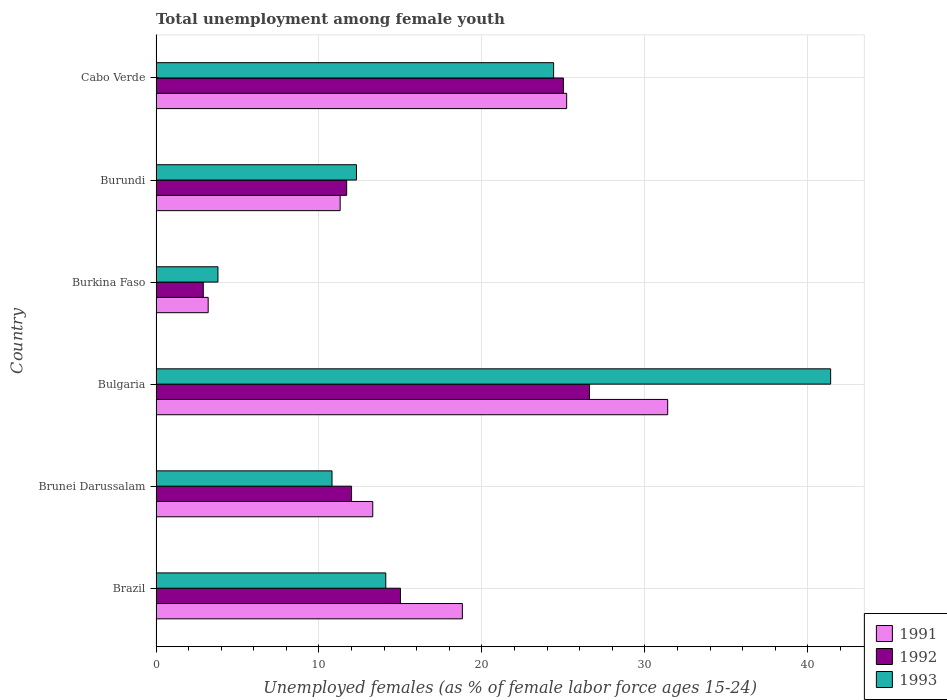How many different coloured bars are there?
Provide a succinct answer. 3. How many groups of bars are there?
Your answer should be very brief. 6. How many bars are there on the 5th tick from the top?
Provide a succinct answer. 3. How many bars are there on the 1st tick from the bottom?
Your answer should be compact. 3. What is the label of the 1st group of bars from the top?
Give a very brief answer. Cabo Verde. In how many cases, is the number of bars for a given country not equal to the number of legend labels?
Ensure brevity in your answer.  0. What is the percentage of unemployed females in in 1993 in Burkina Faso?
Provide a succinct answer. 3.8. Across all countries, what is the maximum percentage of unemployed females in in 1991?
Make the answer very short. 31.4. Across all countries, what is the minimum percentage of unemployed females in in 1991?
Your answer should be very brief. 3.2. In which country was the percentage of unemployed females in in 1991 minimum?
Make the answer very short. Burkina Faso. What is the total percentage of unemployed females in in 1991 in the graph?
Your answer should be very brief. 103.2. What is the difference between the percentage of unemployed females in in 1993 in Brunei Darussalam and that in Cabo Verde?
Offer a very short reply. -13.6. What is the difference between the percentage of unemployed females in in 1992 in Brazil and the percentage of unemployed females in in 1991 in Bulgaria?
Your answer should be very brief. -16.4. What is the average percentage of unemployed females in in 1992 per country?
Provide a short and direct response. 15.53. What is the difference between the percentage of unemployed females in in 1991 and percentage of unemployed females in in 1992 in Brunei Darussalam?
Give a very brief answer. 1.3. What is the ratio of the percentage of unemployed females in in 1991 in Bulgaria to that in Burundi?
Give a very brief answer. 2.78. Is the percentage of unemployed females in in 1993 in Brunei Darussalam less than that in Burundi?
Your answer should be compact. Yes. Is the difference between the percentage of unemployed females in in 1991 in Burundi and Cabo Verde greater than the difference between the percentage of unemployed females in in 1992 in Burundi and Cabo Verde?
Make the answer very short. No. What is the difference between the highest and the second highest percentage of unemployed females in in 1991?
Give a very brief answer. 6.2. What is the difference between the highest and the lowest percentage of unemployed females in in 1992?
Your response must be concise. 23.7. Is the sum of the percentage of unemployed females in in 1991 in Brazil and Bulgaria greater than the maximum percentage of unemployed females in in 1993 across all countries?
Your answer should be very brief. Yes. What does the 1st bar from the top in Brunei Darussalam represents?
Keep it short and to the point. 1993. How many bars are there?
Give a very brief answer. 18. How many countries are there in the graph?
Give a very brief answer. 6. Are the values on the major ticks of X-axis written in scientific E-notation?
Offer a terse response. No. Where does the legend appear in the graph?
Offer a very short reply. Bottom right. How many legend labels are there?
Your answer should be very brief. 3. What is the title of the graph?
Provide a succinct answer. Total unemployment among female youth. Does "2011" appear as one of the legend labels in the graph?
Ensure brevity in your answer.  No. What is the label or title of the X-axis?
Provide a short and direct response. Unemployed females (as % of female labor force ages 15-24). What is the label or title of the Y-axis?
Your response must be concise. Country. What is the Unemployed females (as % of female labor force ages 15-24) in 1991 in Brazil?
Your response must be concise. 18.8. What is the Unemployed females (as % of female labor force ages 15-24) in 1993 in Brazil?
Provide a short and direct response. 14.1. What is the Unemployed females (as % of female labor force ages 15-24) in 1991 in Brunei Darussalam?
Ensure brevity in your answer.  13.3. What is the Unemployed females (as % of female labor force ages 15-24) in 1993 in Brunei Darussalam?
Offer a terse response. 10.8. What is the Unemployed females (as % of female labor force ages 15-24) in 1991 in Bulgaria?
Offer a terse response. 31.4. What is the Unemployed females (as % of female labor force ages 15-24) of 1992 in Bulgaria?
Your answer should be very brief. 26.6. What is the Unemployed females (as % of female labor force ages 15-24) of 1993 in Bulgaria?
Ensure brevity in your answer.  41.4. What is the Unemployed females (as % of female labor force ages 15-24) in 1991 in Burkina Faso?
Provide a succinct answer. 3.2. What is the Unemployed females (as % of female labor force ages 15-24) in 1992 in Burkina Faso?
Offer a terse response. 2.9. What is the Unemployed females (as % of female labor force ages 15-24) of 1993 in Burkina Faso?
Keep it short and to the point. 3.8. What is the Unemployed females (as % of female labor force ages 15-24) of 1991 in Burundi?
Ensure brevity in your answer.  11.3. What is the Unemployed females (as % of female labor force ages 15-24) of 1992 in Burundi?
Provide a short and direct response. 11.7. What is the Unemployed females (as % of female labor force ages 15-24) in 1993 in Burundi?
Make the answer very short. 12.3. What is the Unemployed females (as % of female labor force ages 15-24) of 1991 in Cabo Verde?
Your answer should be very brief. 25.2. What is the Unemployed females (as % of female labor force ages 15-24) of 1992 in Cabo Verde?
Your answer should be compact. 25. What is the Unemployed females (as % of female labor force ages 15-24) in 1993 in Cabo Verde?
Offer a terse response. 24.4. Across all countries, what is the maximum Unemployed females (as % of female labor force ages 15-24) of 1991?
Your response must be concise. 31.4. Across all countries, what is the maximum Unemployed females (as % of female labor force ages 15-24) in 1992?
Your answer should be compact. 26.6. Across all countries, what is the maximum Unemployed females (as % of female labor force ages 15-24) of 1993?
Your answer should be very brief. 41.4. Across all countries, what is the minimum Unemployed females (as % of female labor force ages 15-24) in 1991?
Keep it short and to the point. 3.2. Across all countries, what is the minimum Unemployed females (as % of female labor force ages 15-24) in 1992?
Give a very brief answer. 2.9. Across all countries, what is the minimum Unemployed females (as % of female labor force ages 15-24) in 1993?
Ensure brevity in your answer.  3.8. What is the total Unemployed females (as % of female labor force ages 15-24) in 1991 in the graph?
Give a very brief answer. 103.2. What is the total Unemployed females (as % of female labor force ages 15-24) in 1992 in the graph?
Offer a very short reply. 93.2. What is the total Unemployed females (as % of female labor force ages 15-24) in 1993 in the graph?
Provide a short and direct response. 106.8. What is the difference between the Unemployed females (as % of female labor force ages 15-24) of 1991 in Brazil and that in Brunei Darussalam?
Your answer should be very brief. 5.5. What is the difference between the Unemployed females (as % of female labor force ages 15-24) of 1992 in Brazil and that in Brunei Darussalam?
Provide a short and direct response. 3. What is the difference between the Unemployed females (as % of female labor force ages 15-24) of 1991 in Brazil and that in Bulgaria?
Offer a terse response. -12.6. What is the difference between the Unemployed females (as % of female labor force ages 15-24) of 1993 in Brazil and that in Bulgaria?
Provide a short and direct response. -27.3. What is the difference between the Unemployed females (as % of female labor force ages 15-24) in 1993 in Brazil and that in Burkina Faso?
Offer a terse response. 10.3. What is the difference between the Unemployed females (as % of female labor force ages 15-24) of 1992 in Brazil and that in Burundi?
Offer a very short reply. 3.3. What is the difference between the Unemployed females (as % of female labor force ages 15-24) in 1993 in Brazil and that in Burundi?
Your answer should be compact. 1.8. What is the difference between the Unemployed females (as % of female labor force ages 15-24) in 1991 in Brazil and that in Cabo Verde?
Your response must be concise. -6.4. What is the difference between the Unemployed females (as % of female labor force ages 15-24) of 1992 in Brazil and that in Cabo Verde?
Ensure brevity in your answer.  -10. What is the difference between the Unemployed females (as % of female labor force ages 15-24) in 1993 in Brazil and that in Cabo Verde?
Your answer should be very brief. -10.3. What is the difference between the Unemployed females (as % of female labor force ages 15-24) in 1991 in Brunei Darussalam and that in Bulgaria?
Keep it short and to the point. -18.1. What is the difference between the Unemployed females (as % of female labor force ages 15-24) in 1992 in Brunei Darussalam and that in Bulgaria?
Ensure brevity in your answer.  -14.6. What is the difference between the Unemployed females (as % of female labor force ages 15-24) of 1993 in Brunei Darussalam and that in Bulgaria?
Your response must be concise. -30.6. What is the difference between the Unemployed females (as % of female labor force ages 15-24) in 1991 in Brunei Darussalam and that in Burkina Faso?
Your answer should be very brief. 10.1. What is the difference between the Unemployed females (as % of female labor force ages 15-24) in 1992 in Brunei Darussalam and that in Burkina Faso?
Your response must be concise. 9.1. What is the difference between the Unemployed females (as % of female labor force ages 15-24) in 1993 in Brunei Darussalam and that in Burkina Faso?
Your response must be concise. 7. What is the difference between the Unemployed females (as % of female labor force ages 15-24) of 1991 in Brunei Darussalam and that in Burundi?
Offer a terse response. 2. What is the difference between the Unemployed females (as % of female labor force ages 15-24) of 1992 in Brunei Darussalam and that in Burundi?
Ensure brevity in your answer.  0.3. What is the difference between the Unemployed females (as % of female labor force ages 15-24) of 1991 in Bulgaria and that in Burkina Faso?
Offer a terse response. 28.2. What is the difference between the Unemployed females (as % of female labor force ages 15-24) in 1992 in Bulgaria and that in Burkina Faso?
Your answer should be compact. 23.7. What is the difference between the Unemployed females (as % of female labor force ages 15-24) in 1993 in Bulgaria and that in Burkina Faso?
Your answer should be compact. 37.6. What is the difference between the Unemployed females (as % of female labor force ages 15-24) in 1991 in Bulgaria and that in Burundi?
Offer a very short reply. 20.1. What is the difference between the Unemployed females (as % of female labor force ages 15-24) in 1993 in Bulgaria and that in Burundi?
Provide a succinct answer. 29.1. What is the difference between the Unemployed females (as % of female labor force ages 15-24) of 1993 in Bulgaria and that in Cabo Verde?
Provide a short and direct response. 17. What is the difference between the Unemployed females (as % of female labor force ages 15-24) in 1991 in Burkina Faso and that in Burundi?
Give a very brief answer. -8.1. What is the difference between the Unemployed females (as % of female labor force ages 15-24) in 1991 in Burkina Faso and that in Cabo Verde?
Ensure brevity in your answer.  -22. What is the difference between the Unemployed females (as % of female labor force ages 15-24) in 1992 in Burkina Faso and that in Cabo Verde?
Ensure brevity in your answer.  -22.1. What is the difference between the Unemployed females (as % of female labor force ages 15-24) of 1993 in Burkina Faso and that in Cabo Verde?
Offer a very short reply. -20.6. What is the difference between the Unemployed females (as % of female labor force ages 15-24) in 1991 in Burundi and that in Cabo Verde?
Provide a succinct answer. -13.9. What is the difference between the Unemployed females (as % of female labor force ages 15-24) in 1991 in Brazil and the Unemployed females (as % of female labor force ages 15-24) in 1992 in Bulgaria?
Give a very brief answer. -7.8. What is the difference between the Unemployed females (as % of female labor force ages 15-24) in 1991 in Brazil and the Unemployed females (as % of female labor force ages 15-24) in 1993 in Bulgaria?
Keep it short and to the point. -22.6. What is the difference between the Unemployed females (as % of female labor force ages 15-24) of 1992 in Brazil and the Unemployed females (as % of female labor force ages 15-24) of 1993 in Bulgaria?
Provide a succinct answer. -26.4. What is the difference between the Unemployed females (as % of female labor force ages 15-24) of 1991 in Brazil and the Unemployed females (as % of female labor force ages 15-24) of 1993 in Burkina Faso?
Your answer should be very brief. 15. What is the difference between the Unemployed females (as % of female labor force ages 15-24) of 1991 in Brazil and the Unemployed females (as % of female labor force ages 15-24) of 1993 in Burundi?
Make the answer very short. 6.5. What is the difference between the Unemployed females (as % of female labor force ages 15-24) of 1991 in Brazil and the Unemployed females (as % of female labor force ages 15-24) of 1993 in Cabo Verde?
Provide a succinct answer. -5.6. What is the difference between the Unemployed females (as % of female labor force ages 15-24) in 1991 in Brunei Darussalam and the Unemployed females (as % of female labor force ages 15-24) in 1993 in Bulgaria?
Your answer should be compact. -28.1. What is the difference between the Unemployed females (as % of female labor force ages 15-24) in 1992 in Brunei Darussalam and the Unemployed females (as % of female labor force ages 15-24) in 1993 in Bulgaria?
Ensure brevity in your answer.  -29.4. What is the difference between the Unemployed females (as % of female labor force ages 15-24) of 1991 in Brunei Darussalam and the Unemployed females (as % of female labor force ages 15-24) of 1992 in Burkina Faso?
Your answer should be very brief. 10.4. What is the difference between the Unemployed females (as % of female labor force ages 15-24) in 1991 in Brunei Darussalam and the Unemployed females (as % of female labor force ages 15-24) in 1993 in Burundi?
Offer a terse response. 1. What is the difference between the Unemployed females (as % of female labor force ages 15-24) of 1991 in Brunei Darussalam and the Unemployed females (as % of female labor force ages 15-24) of 1992 in Cabo Verde?
Your answer should be very brief. -11.7. What is the difference between the Unemployed females (as % of female labor force ages 15-24) of 1991 in Brunei Darussalam and the Unemployed females (as % of female labor force ages 15-24) of 1993 in Cabo Verde?
Your response must be concise. -11.1. What is the difference between the Unemployed females (as % of female labor force ages 15-24) of 1991 in Bulgaria and the Unemployed females (as % of female labor force ages 15-24) of 1992 in Burkina Faso?
Make the answer very short. 28.5. What is the difference between the Unemployed females (as % of female labor force ages 15-24) in 1991 in Bulgaria and the Unemployed females (as % of female labor force ages 15-24) in 1993 in Burkina Faso?
Offer a very short reply. 27.6. What is the difference between the Unemployed females (as % of female labor force ages 15-24) in 1992 in Bulgaria and the Unemployed females (as % of female labor force ages 15-24) in 1993 in Burkina Faso?
Offer a terse response. 22.8. What is the difference between the Unemployed females (as % of female labor force ages 15-24) in 1992 in Bulgaria and the Unemployed females (as % of female labor force ages 15-24) in 1993 in Burundi?
Keep it short and to the point. 14.3. What is the difference between the Unemployed females (as % of female labor force ages 15-24) in 1991 in Bulgaria and the Unemployed females (as % of female labor force ages 15-24) in 1992 in Cabo Verde?
Keep it short and to the point. 6.4. What is the difference between the Unemployed females (as % of female labor force ages 15-24) in 1991 in Bulgaria and the Unemployed females (as % of female labor force ages 15-24) in 1993 in Cabo Verde?
Keep it short and to the point. 7. What is the difference between the Unemployed females (as % of female labor force ages 15-24) of 1991 in Burkina Faso and the Unemployed females (as % of female labor force ages 15-24) of 1992 in Burundi?
Keep it short and to the point. -8.5. What is the difference between the Unemployed females (as % of female labor force ages 15-24) of 1991 in Burkina Faso and the Unemployed females (as % of female labor force ages 15-24) of 1993 in Burundi?
Ensure brevity in your answer.  -9.1. What is the difference between the Unemployed females (as % of female labor force ages 15-24) of 1992 in Burkina Faso and the Unemployed females (as % of female labor force ages 15-24) of 1993 in Burundi?
Your response must be concise. -9.4. What is the difference between the Unemployed females (as % of female labor force ages 15-24) in 1991 in Burkina Faso and the Unemployed females (as % of female labor force ages 15-24) in 1992 in Cabo Verde?
Offer a terse response. -21.8. What is the difference between the Unemployed females (as % of female labor force ages 15-24) of 1991 in Burkina Faso and the Unemployed females (as % of female labor force ages 15-24) of 1993 in Cabo Verde?
Ensure brevity in your answer.  -21.2. What is the difference between the Unemployed females (as % of female labor force ages 15-24) of 1992 in Burkina Faso and the Unemployed females (as % of female labor force ages 15-24) of 1993 in Cabo Verde?
Give a very brief answer. -21.5. What is the difference between the Unemployed females (as % of female labor force ages 15-24) in 1991 in Burundi and the Unemployed females (as % of female labor force ages 15-24) in 1992 in Cabo Verde?
Provide a succinct answer. -13.7. What is the difference between the Unemployed females (as % of female labor force ages 15-24) of 1992 in Burundi and the Unemployed females (as % of female labor force ages 15-24) of 1993 in Cabo Verde?
Give a very brief answer. -12.7. What is the average Unemployed females (as % of female labor force ages 15-24) of 1991 per country?
Your response must be concise. 17.2. What is the average Unemployed females (as % of female labor force ages 15-24) of 1992 per country?
Ensure brevity in your answer.  15.53. What is the average Unemployed females (as % of female labor force ages 15-24) in 1993 per country?
Make the answer very short. 17.8. What is the difference between the Unemployed females (as % of female labor force ages 15-24) of 1992 and Unemployed females (as % of female labor force ages 15-24) of 1993 in Brazil?
Provide a succinct answer. 0.9. What is the difference between the Unemployed females (as % of female labor force ages 15-24) in 1991 and Unemployed females (as % of female labor force ages 15-24) in 1992 in Brunei Darussalam?
Offer a very short reply. 1.3. What is the difference between the Unemployed females (as % of female labor force ages 15-24) of 1991 and Unemployed females (as % of female labor force ages 15-24) of 1993 in Brunei Darussalam?
Your response must be concise. 2.5. What is the difference between the Unemployed females (as % of female labor force ages 15-24) in 1992 and Unemployed females (as % of female labor force ages 15-24) in 1993 in Brunei Darussalam?
Ensure brevity in your answer.  1.2. What is the difference between the Unemployed females (as % of female labor force ages 15-24) in 1991 and Unemployed females (as % of female labor force ages 15-24) in 1993 in Bulgaria?
Provide a succinct answer. -10. What is the difference between the Unemployed females (as % of female labor force ages 15-24) in 1992 and Unemployed females (as % of female labor force ages 15-24) in 1993 in Bulgaria?
Provide a short and direct response. -14.8. What is the difference between the Unemployed females (as % of female labor force ages 15-24) in 1991 and Unemployed females (as % of female labor force ages 15-24) in 1992 in Burkina Faso?
Your response must be concise. 0.3. What is the difference between the Unemployed females (as % of female labor force ages 15-24) of 1992 and Unemployed females (as % of female labor force ages 15-24) of 1993 in Burkina Faso?
Your answer should be compact. -0.9. What is the difference between the Unemployed females (as % of female labor force ages 15-24) of 1991 and Unemployed females (as % of female labor force ages 15-24) of 1992 in Burundi?
Your answer should be very brief. -0.4. What is the difference between the Unemployed females (as % of female labor force ages 15-24) in 1992 and Unemployed females (as % of female labor force ages 15-24) in 1993 in Burundi?
Provide a succinct answer. -0.6. What is the difference between the Unemployed females (as % of female labor force ages 15-24) of 1991 and Unemployed females (as % of female labor force ages 15-24) of 1992 in Cabo Verde?
Provide a short and direct response. 0.2. What is the difference between the Unemployed females (as % of female labor force ages 15-24) in 1992 and Unemployed females (as % of female labor force ages 15-24) in 1993 in Cabo Verde?
Your answer should be very brief. 0.6. What is the ratio of the Unemployed females (as % of female labor force ages 15-24) in 1991 in Brazil to that in Brunei Darussalam?
Give a very brief answer. 1.41. What is the ratio of the Unemployed females (as % of female labor force ages 15-24) in 1992 in Brazil to that in Brunei Darussalam?
Provide a short and direct response. 1.25. What is the ratio of the Unemployed females (as % of female labor force ages 15-24) in 1993 in Brazil to that in Brunei Darussalam?
Keep it short and to the point. 1.31. What is the ratio of the Unemployed females (as % of female labor force ages 15-24) in 1991 in Brazil to that in Bulgaria?
Ensure brevity in your answer.  0.6. What is the ratio of the Unemployed females (as % of female labor force ages 15-24) in 1992 in Brazil to that in Bulgaria?
Give a very brief answer. 0.56. What is the ratio of the Unemployed females (as % of female labor force ages 15-24) in 1993 in Brazil to that in Bulgaria?
Keep it short and to the point. 0.34. What is the ratio of the Unemployed females (as % of female labor force ages 15-24) of 1991 in Brazil to that in Burkina Faso?
Your answer should be very brief. 5.88. What is the ratio of the Unemployed females (as % of female labor force ages 15-24) in 1992 in Brazil to that in Burkina Faso?
Provide a succinct answer. 5.17. What is the ratio of the Unemployed females (as % of female labor force ages 15-24) in 1993 in Brazil to that in Burkina Faso?
Make the answer very short. 3.71. What is the ratio of the Unemployed females (as % of female labor force ages 15-24) in 1991 in Brazil to that in Burundi?
Provide a succinct answer. 1.66. What is the ratio of the Unemployed females (as % of female labor force ages 15-24) of 1992 in Brazil to that in Burundi?
Your answer should be compact. 1.28. What is the ratio of the Unemployed females (as % of female labor force ages 15-24) of 1993 in Brazil to that in Burundi?
Your answer should be very brief. 1.15. What is the ratio of the Unemployed females (as % of female labor force ages 15-24) in 1991 in Brazil to that in Cabo Verde?
Keep it short and to the point. 0.75. What is the ratio of the Unemployed females (as % of female labor force ages 15-24) of 1992 in Brazil to that in Cabo Verde?
Your answer should be very brief. 0.6. What is the ratio of the Unemployed females (as % of female labor force ages 15-24) in 1993 in Brazil to that in Cabo Verde?
Your answer should be compact. 0.58. What is the ratio of the Unemployed females (as % of female labor force ages 15-24) of 1991 in Brunei Darussalam to that in Bulgaria?
Offer a terse response. 0.42. What is the ratio of the Unemployed females (as % of female labor force ages 15-24) of 1992 in Brunei Darussalam to that in Bulgaria?
Provide a short and direct response. 0.45. What is the ratio of the Unemployed females (as % of female labor force ages 15-24) in 1993 in Brunei Darussalam to that in Bulgaria?
Offer a very short reply. 0.26. What is the ratio of the Unemployed females (as % of female labor force ages 15-24) of 1991 in Brunei Darussalam to that in Burkina Faso?
Keep it short and to the point. 4.16. What is the ratio of the Unemployed females (as % of female labor force ages 15-24) in 1992 in Brunei Darussalam to that in Burkina Faso?
Offer a very short reply. 4.14. What is the ratio of the Unemployed females (as % of female labor force ages 15-24) in 1993 in Brunei Darussalam to that in Burkina Faso?
Ensure brevity in your answer.  2.84. What is the ratio of the Unemployed females (as % of female labor force ages 15-24) of 1991 in Brunei Darussalam to that in Burundi?
Ensure brevity in your answer.  1.18. What is the ratio of the Unemployed females (as % of female labor force ages 15-24) in 1992 in Brunei Darussalam to that in Burundi?
Offer a very short reply. 1.03. What is the ratio of the Unemployed females (as % of female labor force ages 15-24) in 1993 in Brunei Darussalam to that in Burundi?
Offer a terse response. 0.88. What is the ratio of the Unemployed females (as % of female labor force ages 15-24) of 1991 in Brunei Darussalam to that in Cabo Verde?
Make the answer very short. 0.53. What is the ratio of the Unemployed females (as % of female labor force ages 15-24) of 1992 in Brunei Darussalam to that in Cabo Verde?
Keep it short and to the point. 0.48. What is the ratio of the Unemployed females (as % of female labor force ages 15-24) of 1993 in Brunei Darussalam to that in Cabo Verde?
Your answer should be very brief. 0.44. What is the ratio of the Unemployed females (as % of female labor force ages 15-24) in 1991 in Bulgaria to that in Burkina Faso?
Your response must be concise. 9.81. What is the ratio of the Unemployed females (as % of female labor force ages 15-24) of 1992 in Bulgaria to that in Burkina Faso?
Give a very brief answer. 9.17. What is the ratio of the Unemployed females (as % of female labor force ages 15-24) in 1993 in Bulgaria to that in Burkina Faso?
Provide a succinct answer. 10.89. What is the ratio of the Unemployed females (as % of female labor force ages 15-24) of 1991 in Bulgaria to that in Burundi?
Your answer should be compact. 2.78. What is the ratio of the Unemployed females (as % of female labor force ages 15-24) of 1992 in Bulgaria to that in Burundi?
Provide a short and direct response. 2.27. What is the ratio of the Unemployed females (as % of female labor force ages 15-24) in 1993 in Bulgaria to that in Burundi?
Provide a succinct answer. 3.37. What is the ratio of the Unemployed females (as % of female labor force ages 15-24) of 1991 in Bulgaria to that in Cabo Verde?
Your response must be concise. 1.25. What is the ratio of the Unemployed females (as % of female labor force ages 15-24) of 1992 in Bulgaria to that in Cabo Verde?
Offer a terse response. 1.06. What is the ratio of the Unemployed females (as % of female labor force ages 15-24) in 1993 in Bulgaria to that in Cabo Verde?
Your answer should be very brief. 1.7. What is the ratio of the Unemployed females (as % of female labor force ages 15-24) of 1991 in Burkina Faso to that in Burundi?
Make the answer very short. 0.28. What is the ratio of the Unemployed females (as % of female labor force ages 15-24) in 1992 in Burkina Faso to that in Burundi?
Offer a terse response. 0.25. What is the ratio of the Unemployed females (as % of female labor force ages 15-24) of 1993 in Burkina Faso to that in Burundi?
Provide a succinct answer. 0.31. What is the ratio of the Unemployed females (as % of female labor force ages 15-24) in 1991 in Burkina Faso to that in Cabo Verde?
Provide a succinct answer. 0.13. What is the ratio of the Unemployed females (as % of female labor force ages 15-24) of 1992 in Burkina Faso to that in Cabo Verde?
Ensure brevity in your answer.  0.12. What is the ratio of the Unemployed females (as % of female labor force ages 15-24) in 1993 in Burkina Faso to that in Cabo Verde?
Provide a succinct answer. 0.16. What is the ratio of the Unemployed females (as % of female labor force ages 15-24) in 1991 in Burundi to that in Cabo Verde?
Your response must be concise. 0.45. What is the ratio of the Unemployed females (as % of female labor force ages 15-24) in 1992 in Burundi to that in Cabo Verde?
Offer a terse response. 0.47. What is the ratio of the Unemployed females (as % of female labor force ages 15-24) of 1993 in Burundi to that in Cabo Verde?
Keep it short and to the point. 0.5. What is the difference between the highest and the second highest Unemployed females (as % of female labor force ages 15-24) in 1991?
Provide a succinct answer. 6.2. What is the difference between the highest and the lowest Unemployed females (as % of female labor force ages 15-24) in 1991?
Keep it short and to the point. 28.2. What is the difference between the highest and the lowest Unemployed females (as % of female labor force ages 15-24) in 1992?
Your response must be concise. 23.7. What is the difference between the highest and the lowest Unemployed females (as % of female labor force ages 15-24) of 1993?
Your answer should be compact. 37.6. 